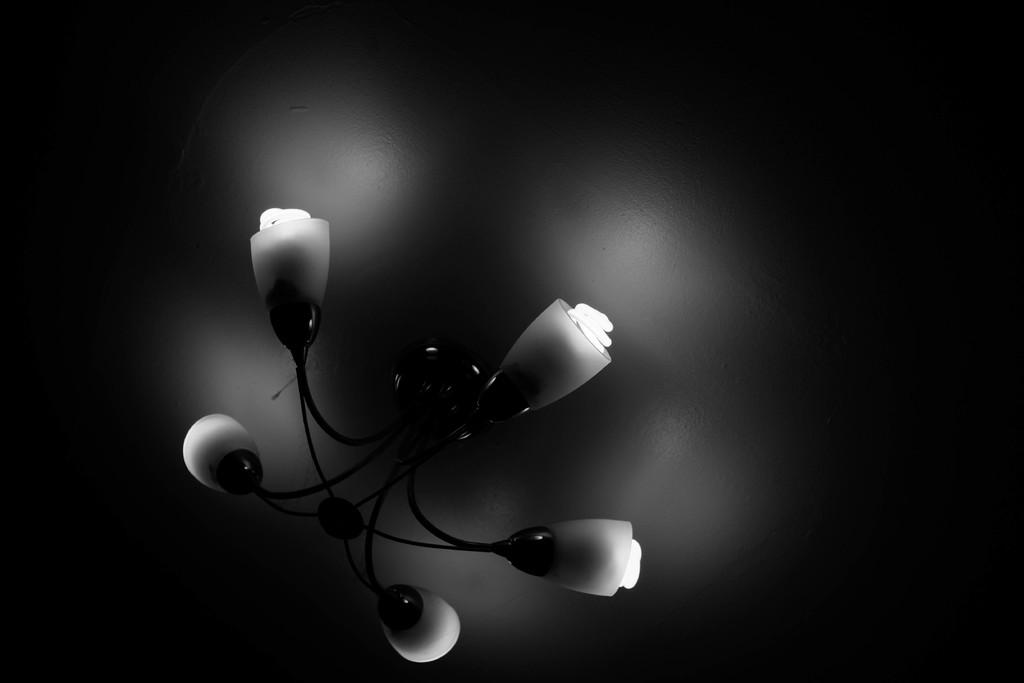What is the color scheme of the image? The image is black and white. What can be seen hanging from the ceiling in the image? There is a chandelier on the ceiling. Are the lights on the chandelier turned on? Yes, the chandelier has lights on. What type of army is depicted in the image? There is no army present in the image; it features a black and white chandelier with lights on. What experience can be gained from the image? The image is a static representation of a chandelier and does not offer any interactive or experiential elements. 